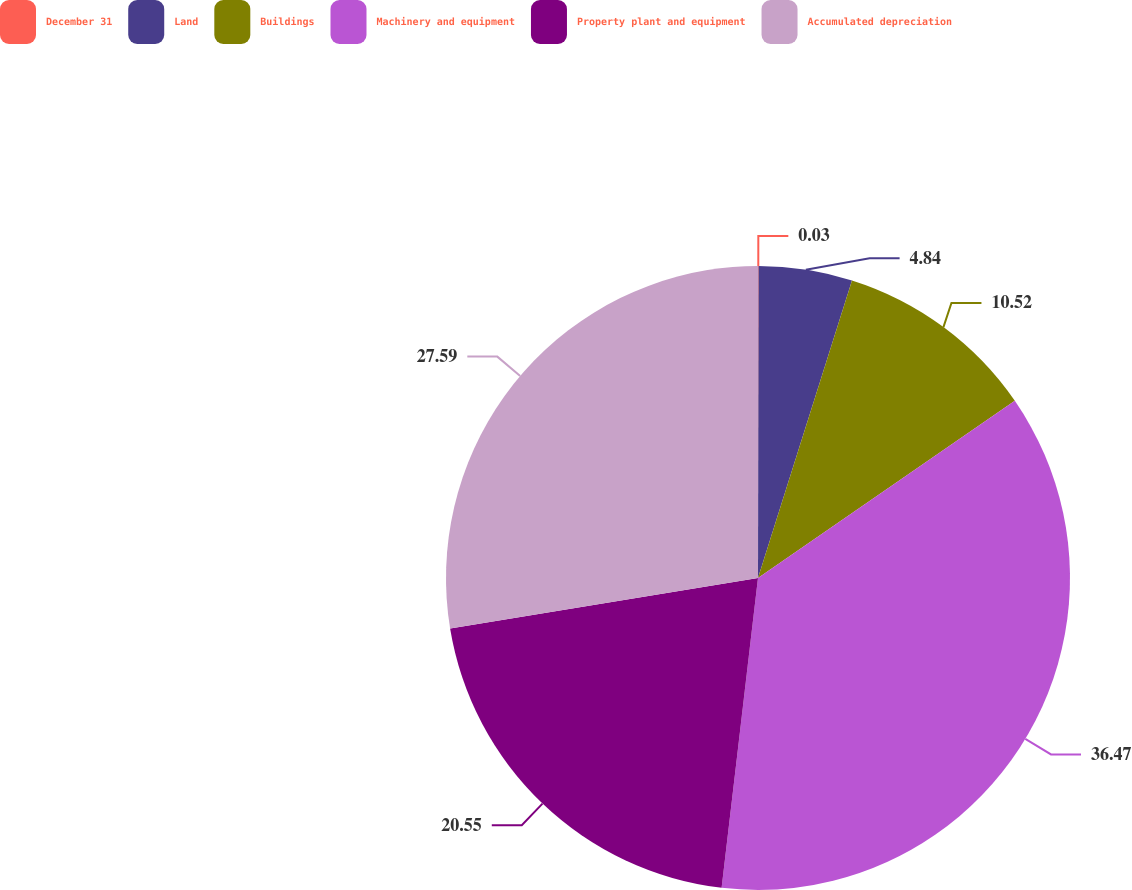Convert chart. <chart><loc_0><loc_0><loc_500><loc_500><pie_chart><fcel>December 31<fcel>Land<fcel>Buildings<fcel>Machinery and equipment<fcel>Property plant and equipment<fcel>Accumulated depreciation<nl><fcel>0.03%<fcel>4.84%<fcel>10.52%<fcel>36.47%<fcel>20.55%<fcel>27.59%<nl></chart> 